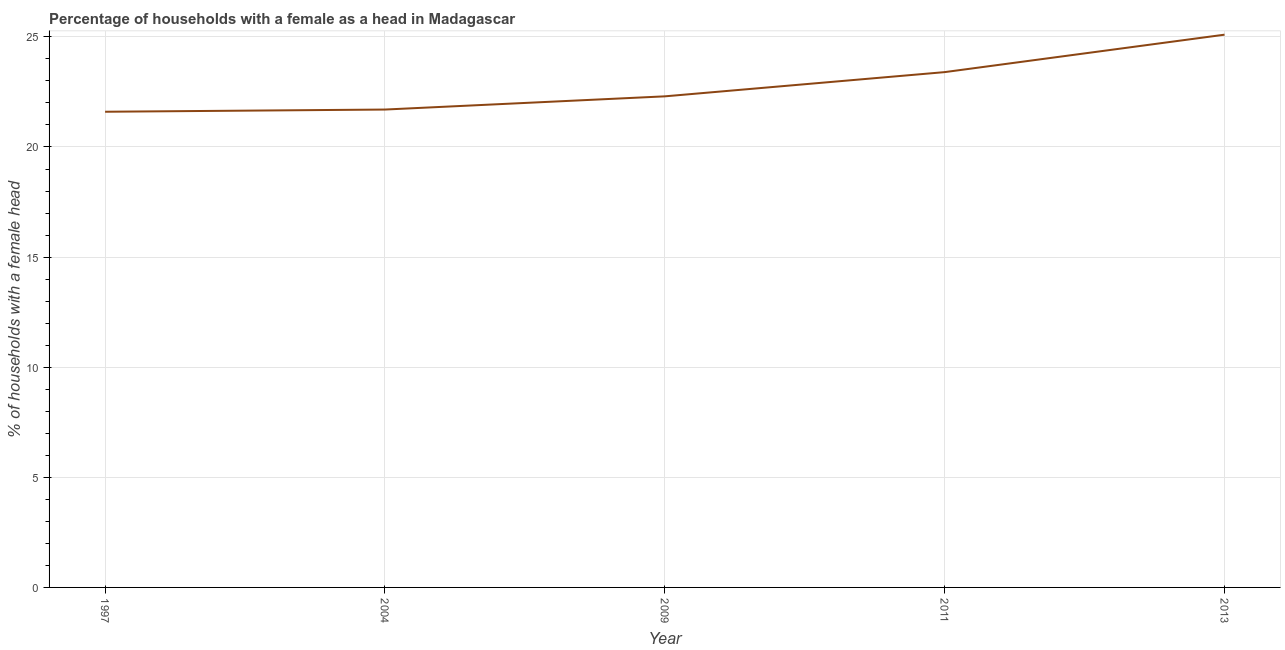What is the number of female supervised households in 2004?
Offer a very short reply. 21.7. Across all years, what is the maximum number of female supervised households?
Keep it short and to the point. 25.1. Across all years, what is the minimum number of female supervised households?
Your answer should be compact. 21.6. In which year was the number of female supervised households maximum?
Your answer should be compact. 2013. In which year was the number of female supervised households minimum?
Give a very brief answer. 1997. What is the sum of the number of female supervised households?
Your answer should be very brief. 114.1. What is the difference between the number of female supervised households in 1997 and 2009?
Make the answer very short. -0.7. What is the average number of female supervised households per year?
Ensure brevity in your answer.  22.82. What is the median number of female supervised households?
Your answer should be very brief. 22.3. In how many years, is the number of female supervised households greater than 11 %?
Provide a succinct answer. 5. Do a majority of the years between 2004 and 1997 (inclusive) have number of female supervised households greater than 13 %?
Ensure brevity in your answer.  No. What is the ratio of the number of female supervised households in 2004 to that in 2011?
Make the answer very short. 0.93. Is the number of female supervised households in 1997 less than that in 2004?
Make the answer very short. Yes. What is the difference between the highest and the second highest number of female supervised households?
Offer a terse response. 1.7. What is the difference between the highest and the lowest number of female supervised households?
Offer a terse response. 3.5. In how many years, is the number of female supervised households greater than the average number of female supervised households taken over all years?
Your answer should be very brief. 2. How many lines are there?
Give a very brief answer. 1. How many years are there in the graph?
Your response must be concise. 5. What is the difference between two consecutive major ticks on the Y-axis?
Provide a succinct answer. 5. What is the title of the graph?
Give a very brief answer. Percentage of households with a female as a head in Madagascar. What is the label or title of the Y-axis?
Offer a very short reply. % of households with a female head. What is the % of households with a female head in 1997?
Your answer should be compact. 21.6. What is the % of households with a female head in 2004?
Offer a terse response. 21.7. What is the % of households with a female head of 2009?
Make the answer very short. 22.3. What is the % of households with a female head in 2011?
Offer a very short reply. 23.4. What is the % of households with a female head in 2013?
Your answer should be compact. 25.1. What is the difference between the % of households with a female head in 1997 and 2013?
Ensure brevity in your answer.  -3.5. What is the difference between the % of households with a female head in 2004 and 2009?
Make the answer very short. -0.6. What is the difference between the % of households with a female head in 2009 and 2011?
Offer a very short reply. -1.1. What is the difference between the % of households with a female head in 2009 and 2013?
Ensure brevity in your answer.  -2.8. What is the difference between the % of households with a female head in 2011 and 2013?
Provide a short and direct response. -1.7. What is the ratio of the % of households with a female head in 1997 to that in 2004?
Keep it short and to the point. 0.99. What is the ratio of the % of households with a female head in 1997 to that in 2011?
Offer a very short reply. 0.92. What is the ratio of the % of households with a female head in 1997 to that in 2013?
Your response must be concise. 0.86. What is the ratio of the % of households with a female head in 2004 to that in 2011?
Provide a succinct answer. 0.93. What is the ratio of the % of households with a female head in 2004 to that in 2013?
Give a very brief answer. 0.86. What is the ratio of the % of households with a female head in 2009 to that in 2011?
Provide a succinct answer. 0.95. What is the ratio of the % of households with a female head in 2009 to that in 2013?
Make the answer very short. 0.89. What is the ratio of the % of households with a female head in 2011 to that in 2013?
Offer a very short reply. 0.93. 